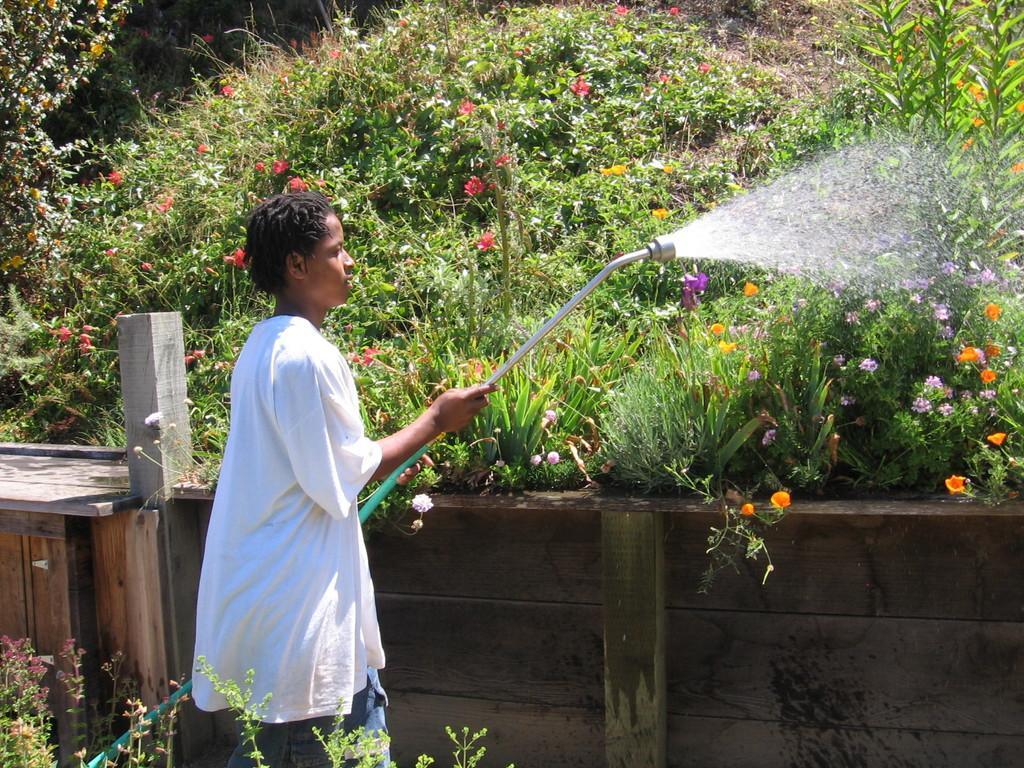How would you summarize this image in a sentence or two? In this image, we can see a person standing and watering the plants, we can see some plants and there are some flowers, we can see a small wooden wall. 